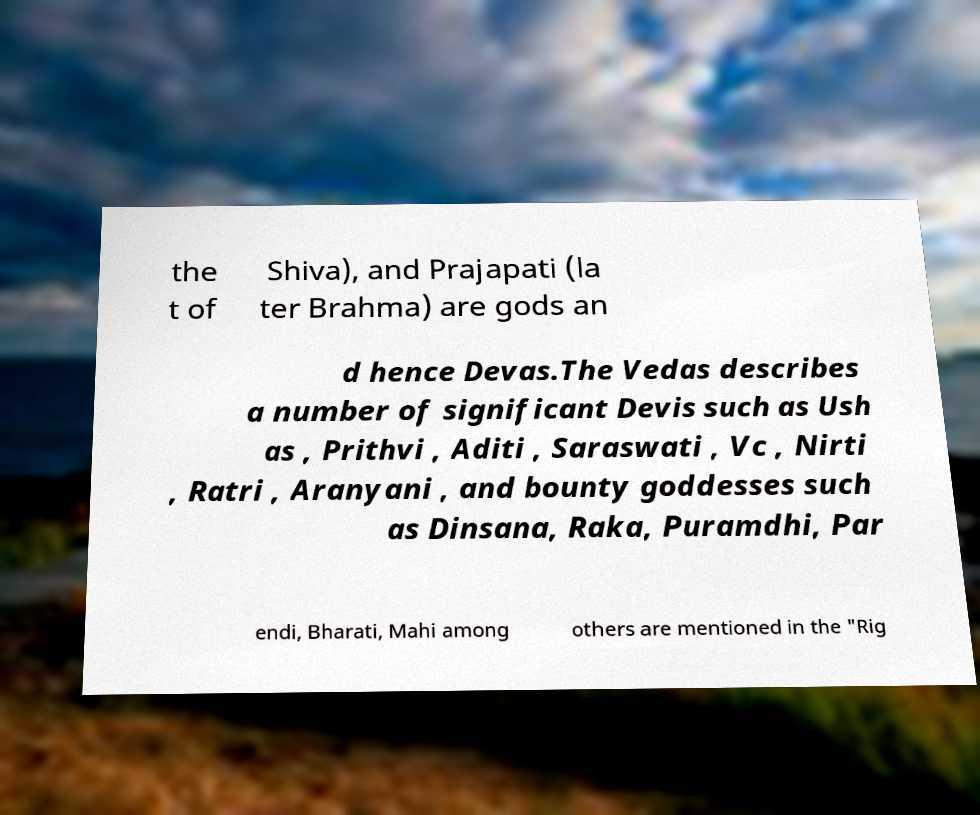There's text embedded in this image that I need extracted. Can you transcribe it verbatim? the t of Shiva), and Prajapati (la ter Brahma) are gods an d hence Devas.The Vedas describes a number of significant Devis such as Ush as , Prithvi , Aditi , Saraswati , Vc , Nirti , Ratri , Aranyani , and bounty goddesses such as Dinsana, Raka, Puramdhi, Par endi, Bharati, Mahi among others are mentioned in the "Rig 